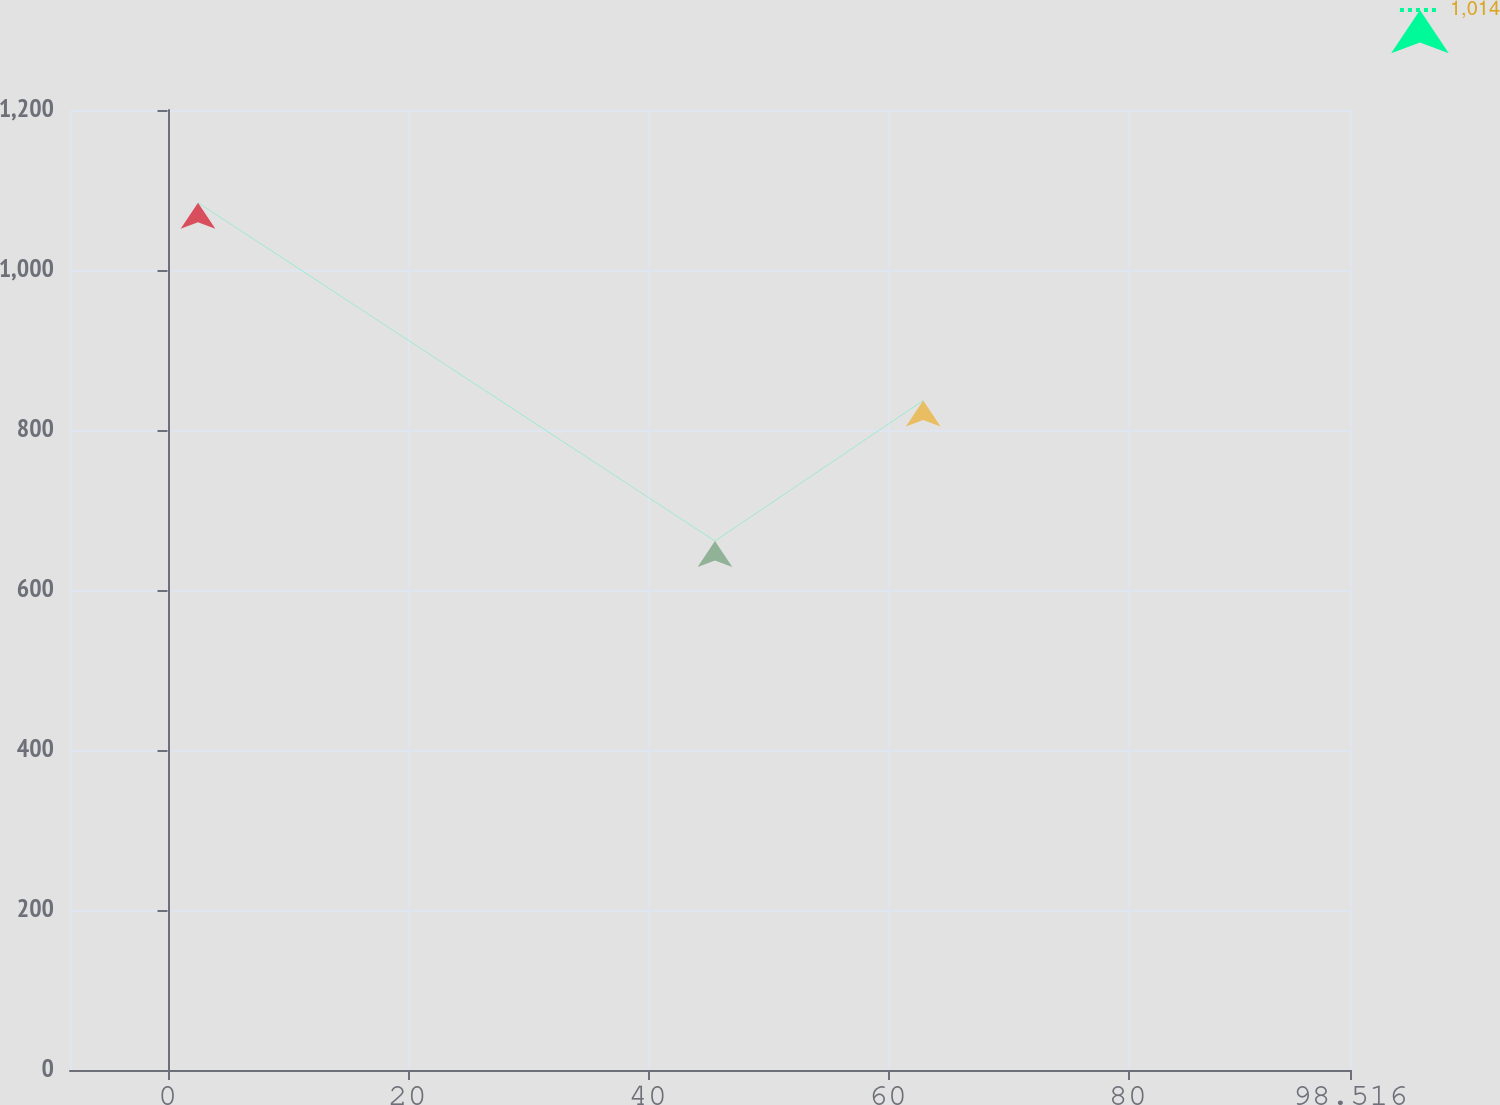Convert chart. <chart><loc_0><loc_0><loc_500><loc_500><line_chart><ecel><fcel>1,014<nl><fcel>2.54<fcel>1084.15<nl><fcel>45.61<fcel>661.19<nl><fcel>62.96<fcel>836.85<nl><fcel>109.18<fcel>549.28<nl></chart> 